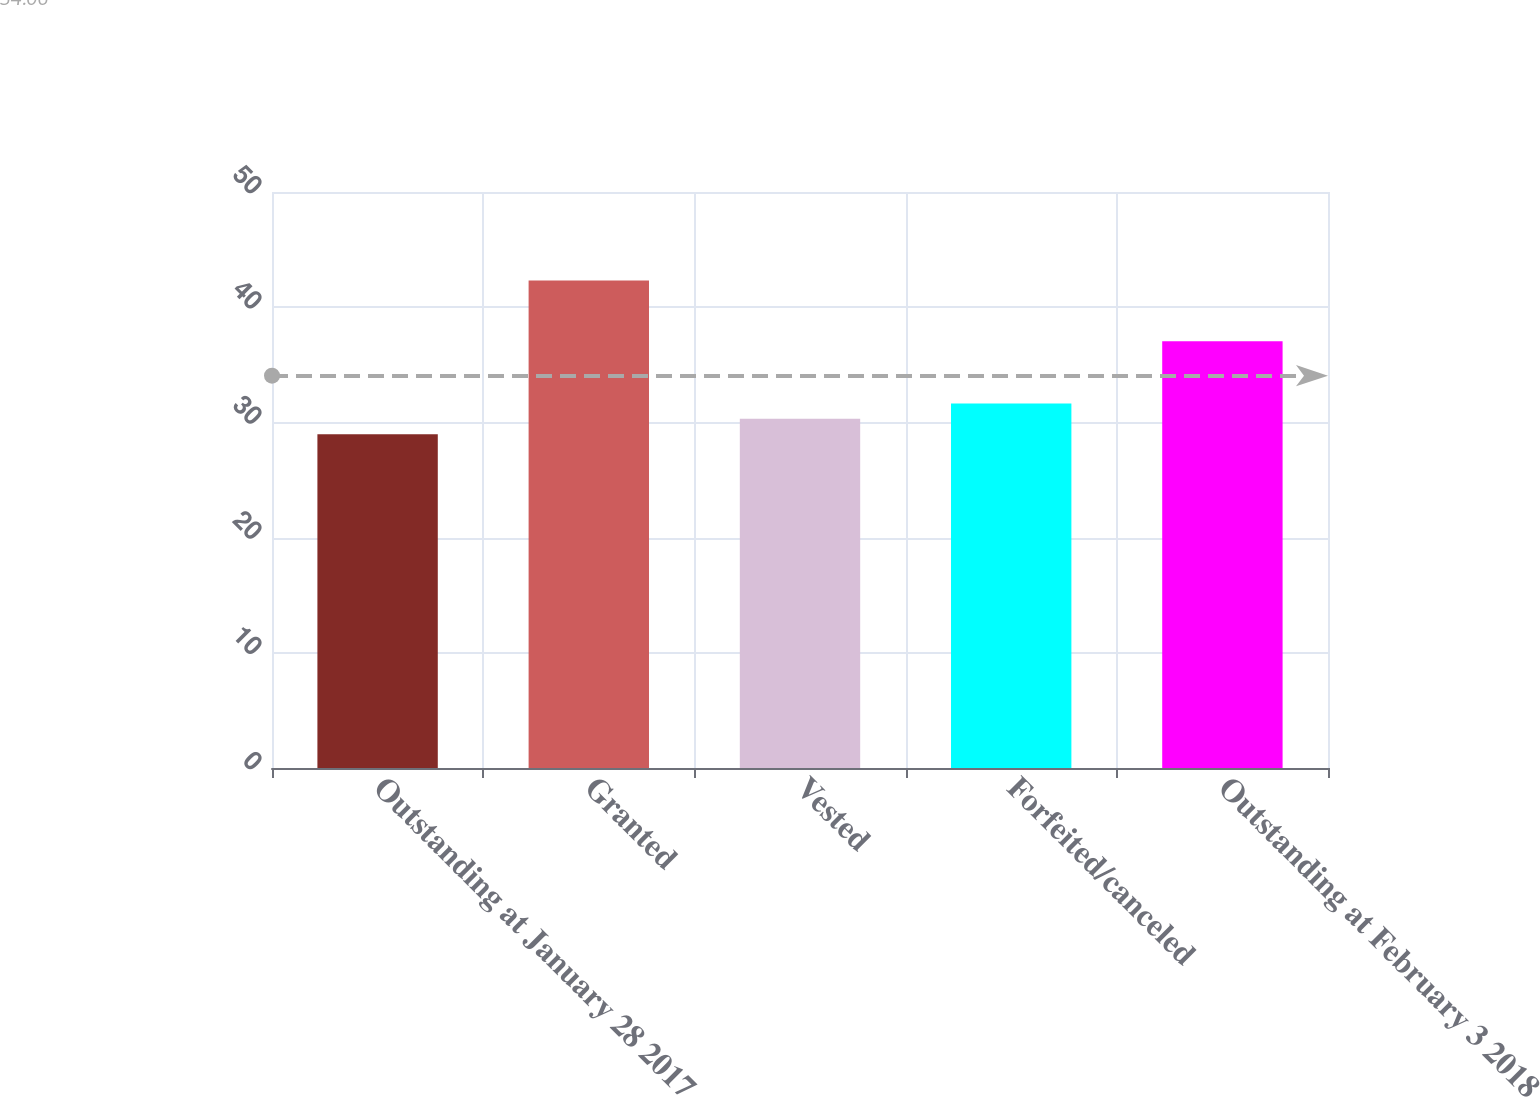Convert chart to OTSL. <chart><loc_0><loc_0><loc_500><loc_500><bar_chart><fcel>Outstanding at January 28 2017<fcel>Granted<fcel>Vested<fcel>Forfeited/canceled<fcel>Outstanding at February 3 2018<nl><fcel>28.98<fcel>42.31<fcel>30.31<fcel>31.64<fcel>37.04<nl></chart> 